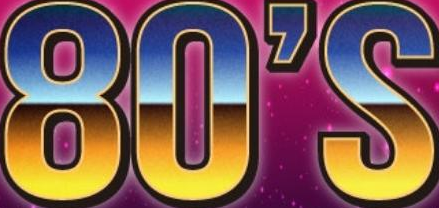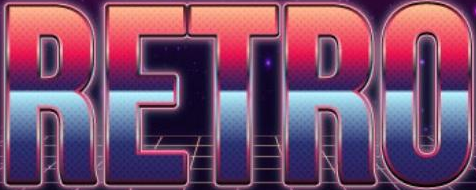Read the text from these images in sequence, separated by a semicolon. 80'S; RETRO 